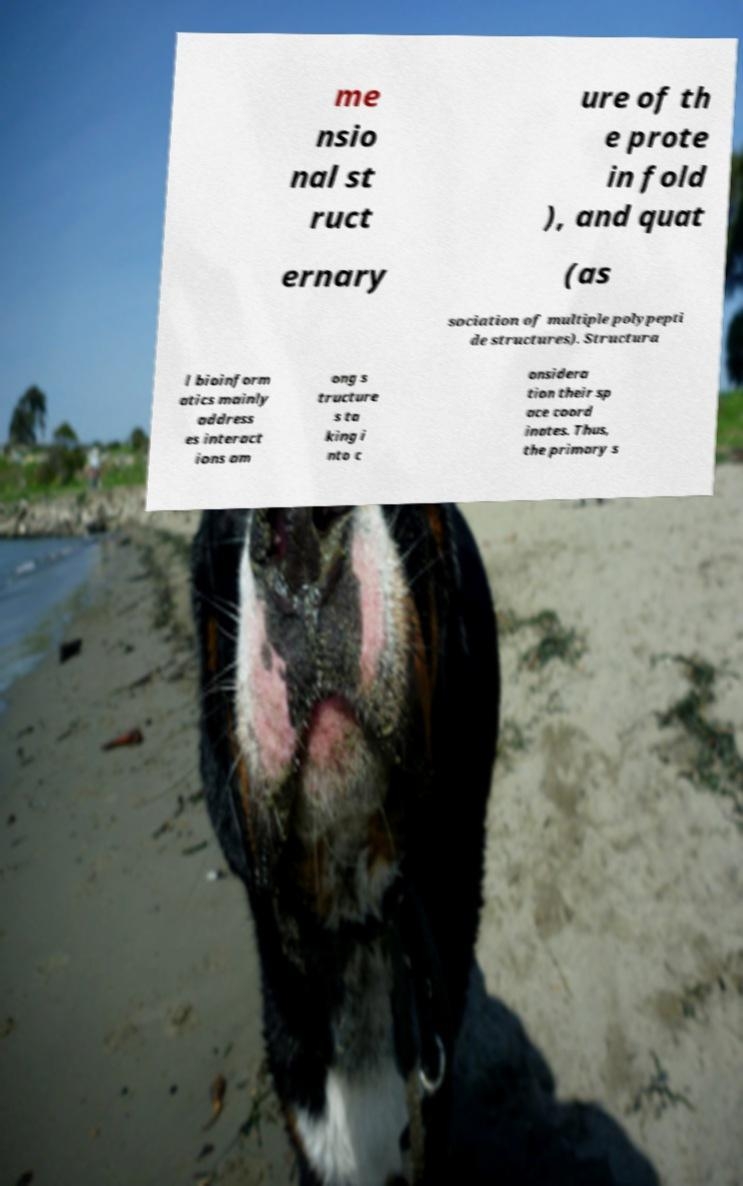What messages or text are displayed in this image? I need them in a readable, typed format. me nsio nal st ruct ure of th e prote in fold ), and quat ernary (as sociation of multiple polypepti de structures). Structura l bioinform atics mainly address es interact ions am ong s tructure s ta king i nto c onsidera tion their sp ace coord inates. Thus, the primary s 